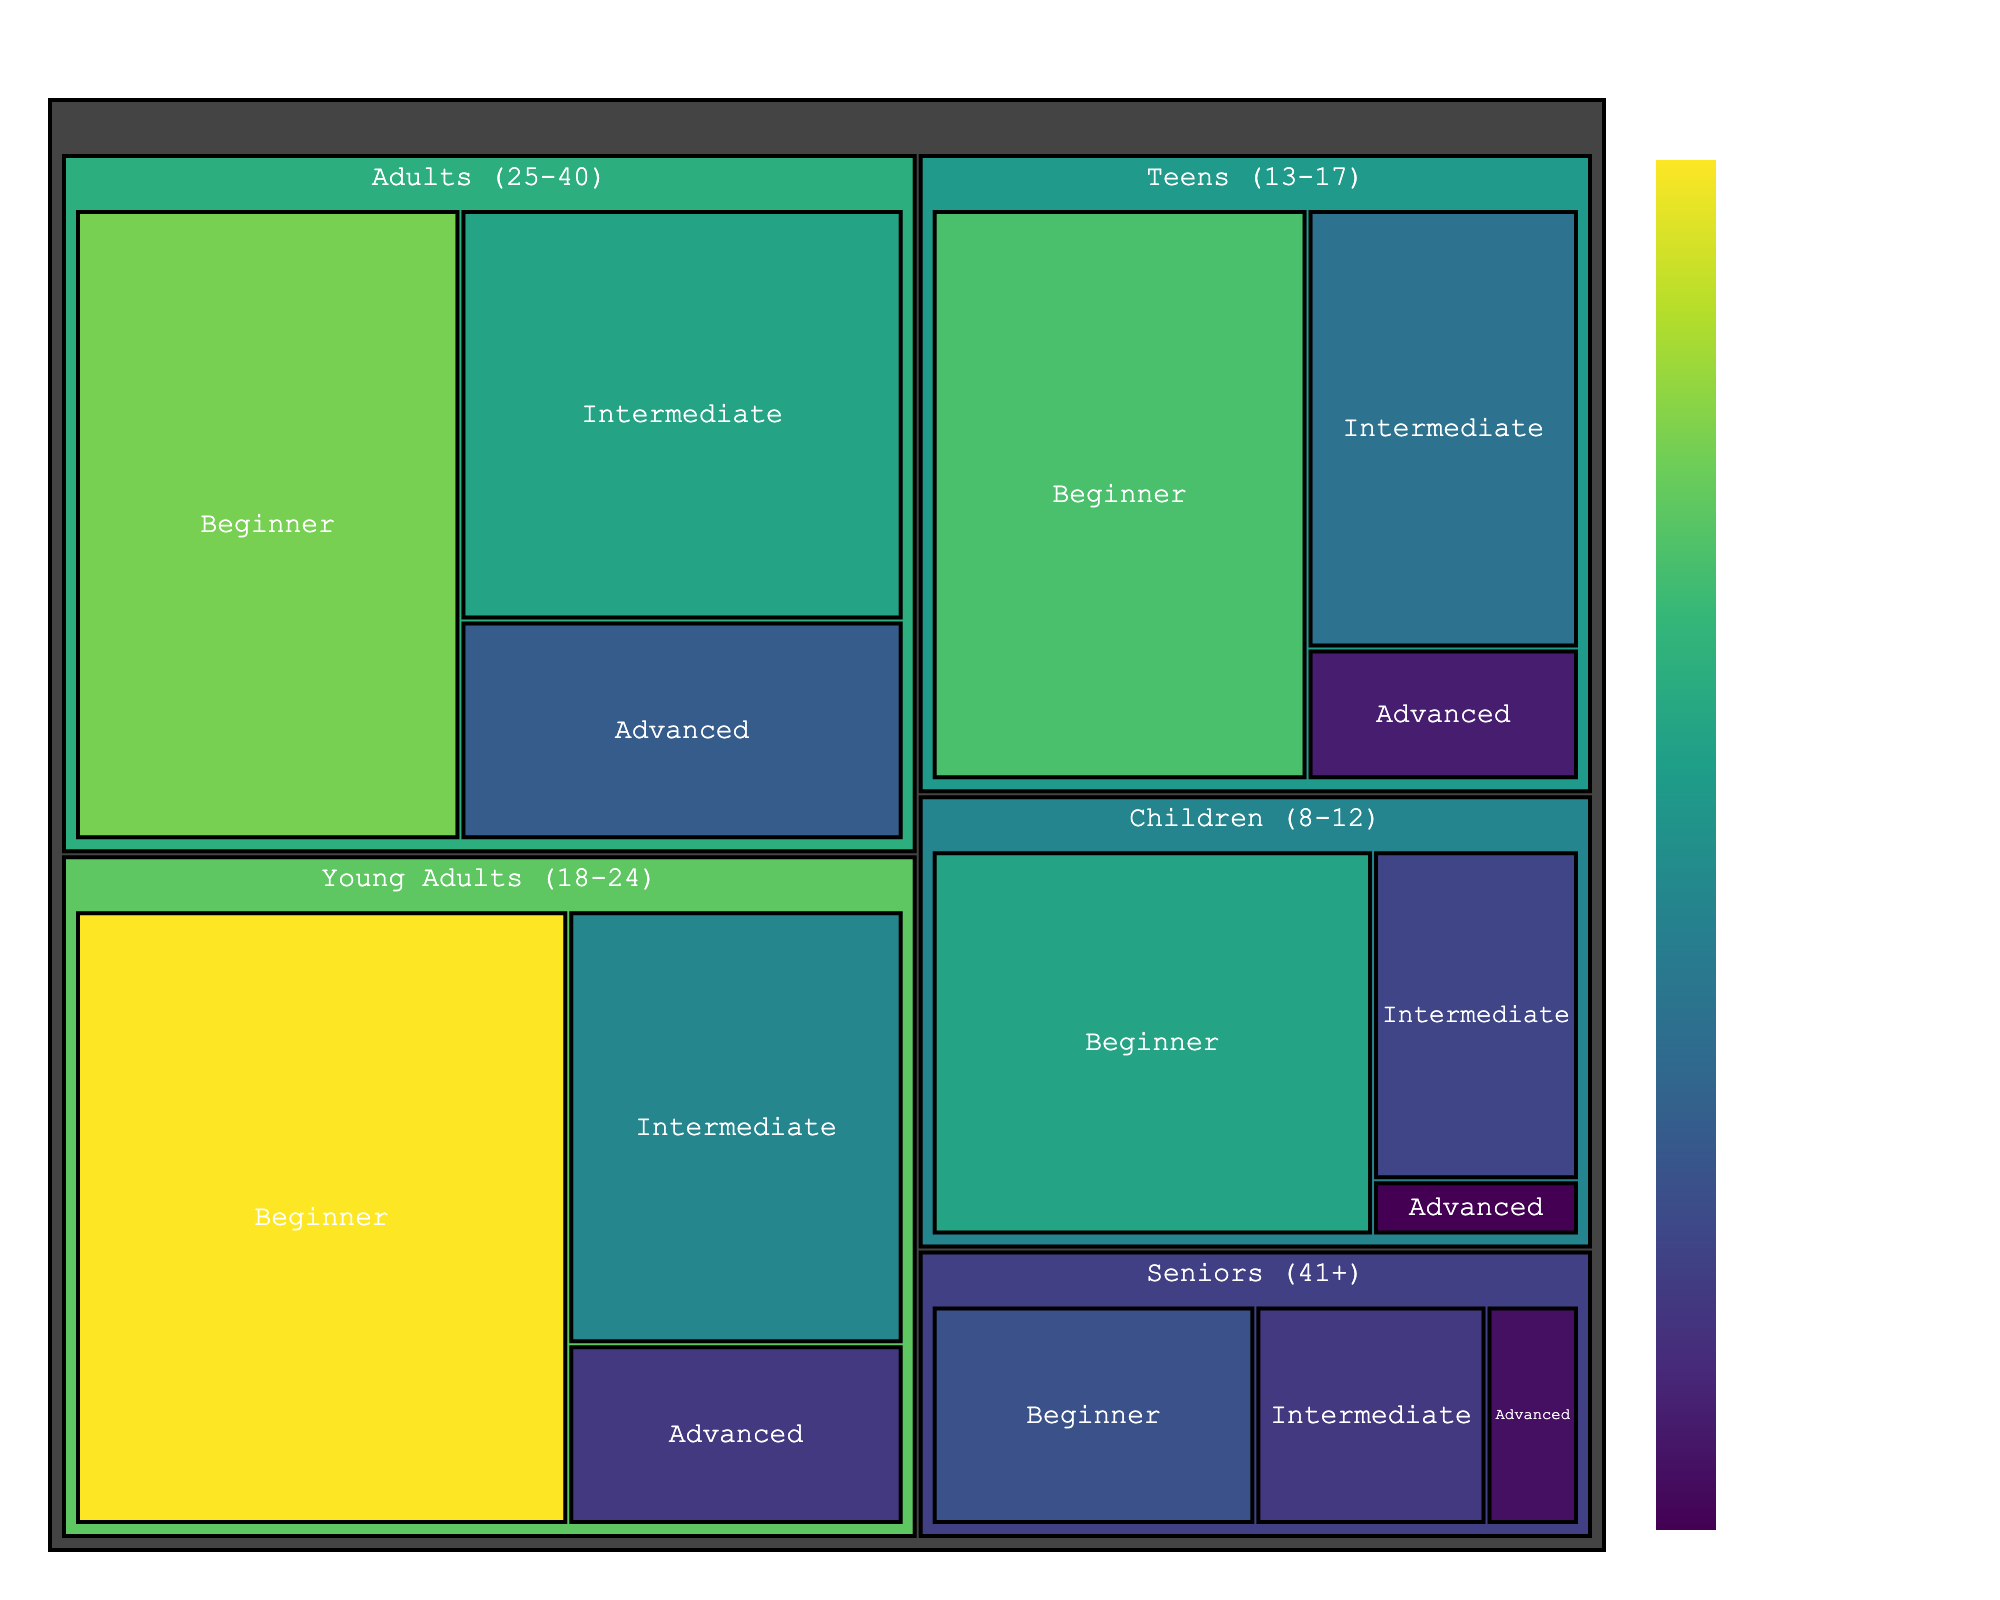What's the title of the figure? The title is typically found at the top of the figure and provides a summary of what the figure represents.
Answer: Student Demographics in Private Acting Classes Which age group has the largest number of Beginner students? From the treemap, identify which age group has the largest section under the 'Beginner' category. The size of the section correlates with the number of students.
Answer: Young Adults (18-24) How many total students are there in the Teens (13-17) age group? Add the number of students in each experience level category (Beginner, Intermediate, Advanced) for the Teens (13-17) age group.
Answer: 31 Compare the number of Intermediate students in the Adults (25-40) and Young Adults (18-24) age groups. Which group has more students? Look at the size of the Intermediate sections for Adults and Young Adults, and compare their values.
Answer: Adults (25-40) Of all age groups, which has the fewest Advanced students? Identify which age group has the smallest section under the 'Advanced' category.
Answer: Children (8-12) What's the total number of students across all age groups and experience levels? Sum up the number of students in all categories listed in the data.
Answer: 152 Which experience level category has the highest number of students in the Seniors (41+) age group? Look at the different experience level sections under the Seniors (41+) age group and identify the one with the largest value.
Answer: Beginner Between Adults (25-40) and Seniors (41+) age groups, which has more Beginner students? Compare the Beginner sections for both Adults and Seniors age groups and see which is larger.
Answer: Adults (25-40) What’s the difference in the number of Advanced students between Young Adults (18-24) and Teens (13-17)? Subtract the number of Advanced students in the Teens age group from the number in the Young Adults age group.
Answer: 2 Which age group has the most uniform distribution of students across all experience levels? Determine which age group has sections (Beginner, Intermediate, Advanced) of similar sizes, indicating a uniform distribution.
Answer: Teens (13-17) 